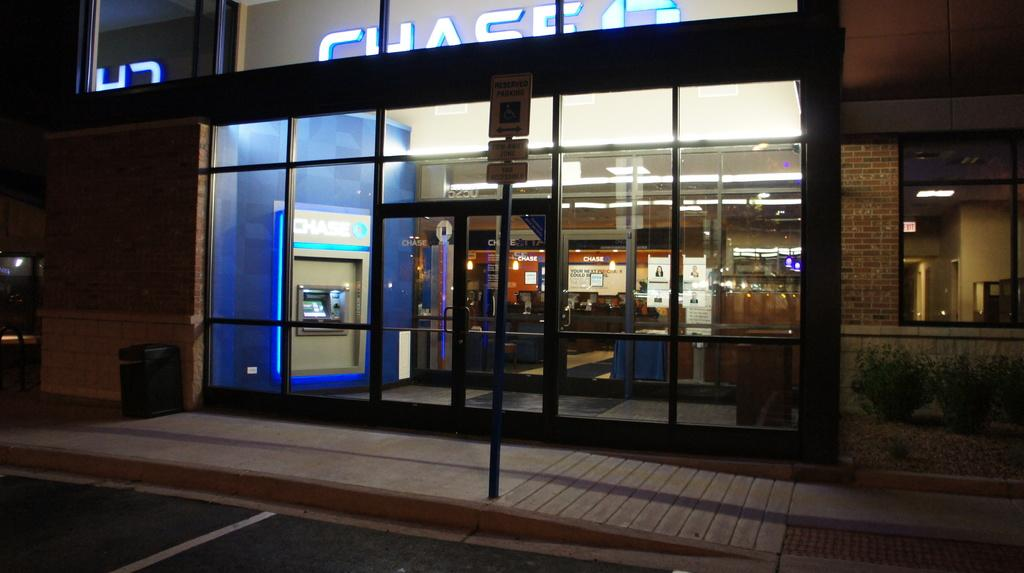<image>
Relay a brief, clear account of the picture shown. A night view of a building with the word chase above. 